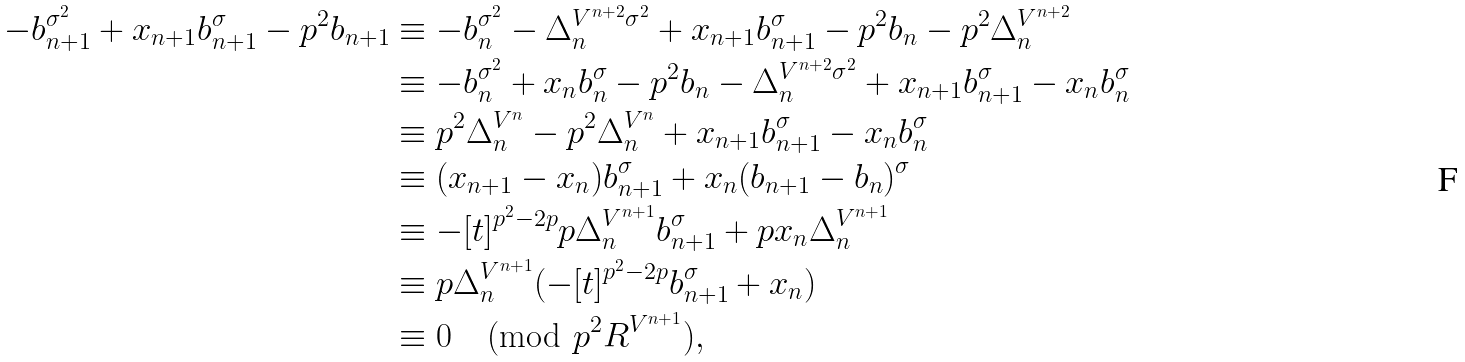<formula> <loc_0><loc_0><loc_500><loc_500>- b _ { n + 1 } ^ { \sigma ^ { 2 } } + x _ { n + 1 } b _ { n + 1 } ^ { \sigma } - p ^ { 2 } b _ { n + 1 } & \equiv - b _ { n } ^ { \sigma ^ { 2 } } - \Delta _ { n } ^ { V ^ { n + 2 } \sigma ^ { 2 } } + x _ { n + 1 } b _ { n + 1 } ^ { \sigma } - p ^ { 2 } b _ { n } - p ^ { 2 } \Delta _ { n } ^ { V ^ { n + 2 } } \\ & \equiv - b _ { n } ^ { \sigma ^ { 2 } } + x _ { n } b _ { n } ^ { \sigma } - p ^ { 2 } b _ { n } - \Delta _ { n } ^ { V ^ { n + 2 } \sigma ^ { 2 } } + x _ { n + 1 } b _ { n + 1 } ^ { \sigma } - x _ { n } b _ { n } ^ { \sigma } \\ & \equiv p ^ { 2 } \Delta _ { n } ^ { V ^ { n } } - p ^ { 2 } \Delta _ { n } ^ { V ^ { n } } + x _ { n + 1 } b _ { n + 1 } ^ { \sigma } - x _ { n } b _ { n } ^ { \sigma } \\ & \equiv ( x _ { n + 1 } - x _ { n } ) b _ { n + 1 } ^ { \sigma } + x _ { n } ( b _ { n + 1 } - b _ { n } ) ^ { \sigma } \\ & \equiv - [ t ] ^ { p ^ { 2 } - 2 p } p \Delta _ { n } ^ { V ^ { n + 1 } } b _ { n + 1 } ^ { \sigma } + p x _ { n } \Delta _ { n } ^ { V ^ { n + 1 } } \\ & \equiv p \Delta _ { n } ^ { V ^ { n + 1 } } ( - [ t ] ^ { p ^ { 2 } - 2 p } b _ { n + 1 } ^ { \sigma } + x _ { n } ) \\ & \equiv 0 \pmod { p ^ { 2 } R ^ { V ^ { n + 1 } } } ,</formula> 